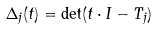Convert formula to latex. <formula><loc_0><loc_0><loc_500><loc_500>\Delta _ { j } ( t ) = \det ( t \cdot I - T _ { j } )</formula> 